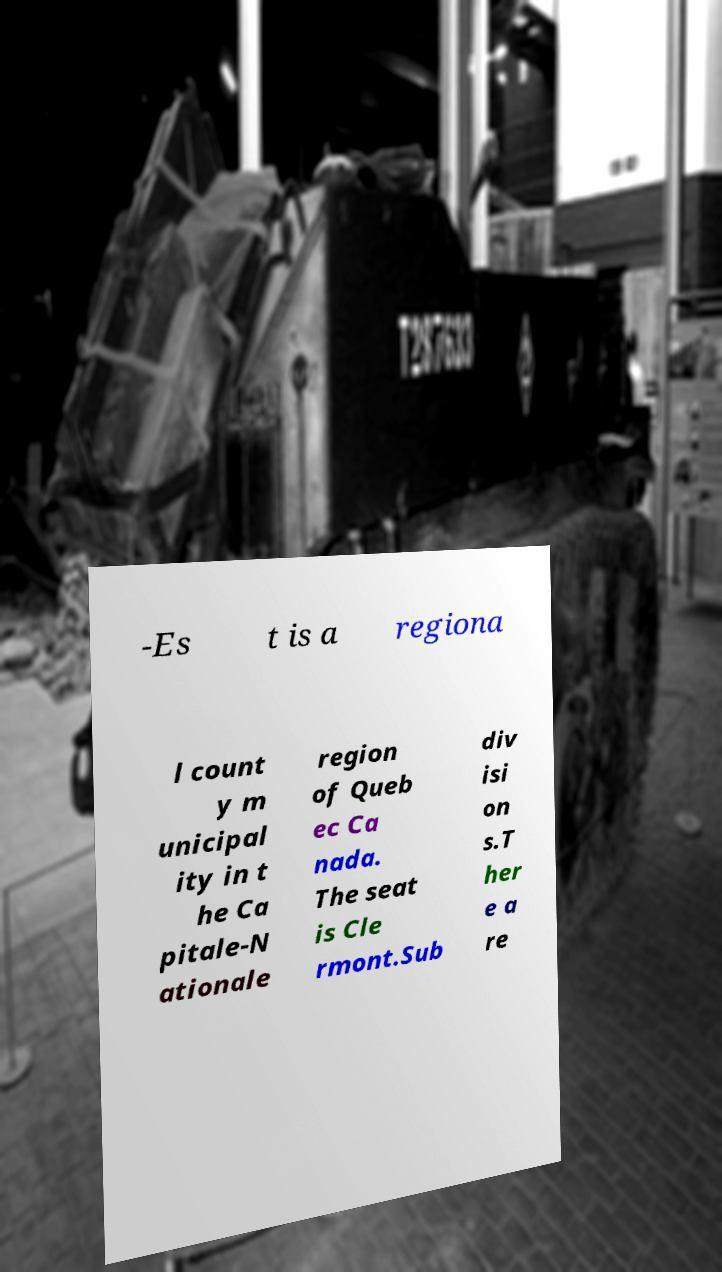Can you accurately transcribe the text from the provided image for me? -Es t is a regiona l count y m unicipal ity in t he Ca pitale-N ationale region of Queb ec Ca nada. The seat is Cle rmont.Sub div isi on s.T her e a re 